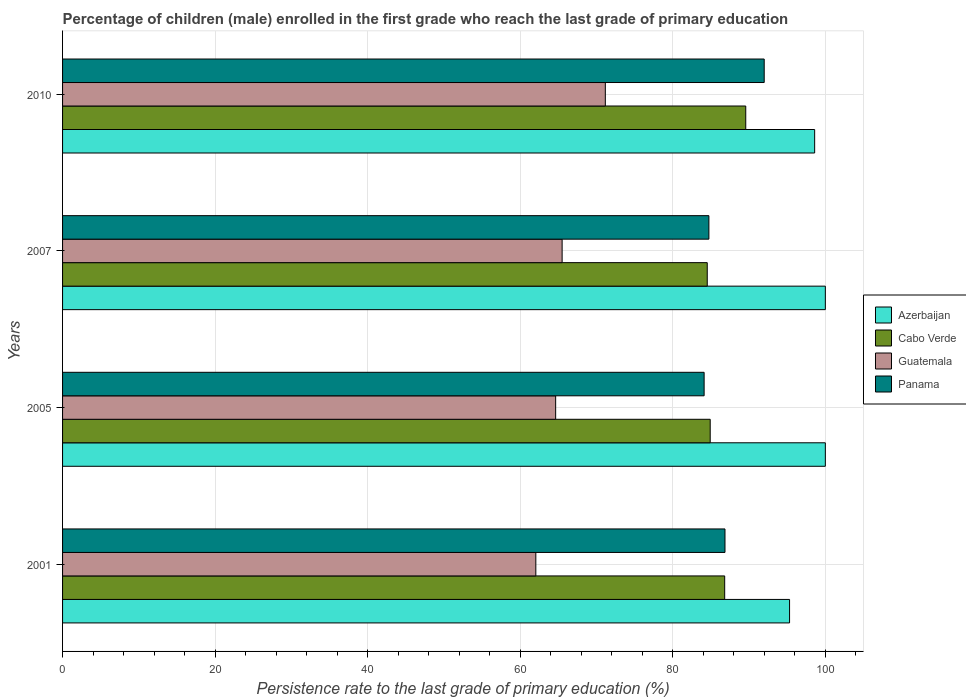How many groups of bars are there?
Ensure brevity in your answer.  4. How many bars are there on the 4th tick from the top?
Your answer should be compact. 4. What is the persistence rate of children in Cabo Verde in 2001?
Give a very brief answer. 86.81. Across all years, what is the minimum persistence rate of children in Cabo Verde?
Offer a terse response. 84.52. What is the total persistence rate of children in Cabo Verde in the graph?
Offer a very short reply. 345.8. What is the difference between the persistence rate of children in Cabo Verde in 2001 and that in 2005?
Your response must be concise. 1.9. What is the difference between the persistence rate of children in Cabo Verde in 2007 and the persistence rate of children in Guatemala in 2001?
Provide a short and direct response. 22.47. What is the average persistence rate of children in Azerbaijan per year?
Offer a very short reply. 98.48. In the year 2007, what is the difference between the persistence rate of children in Guatemala and persistence rate of children in Azerbaijan?
Provide a succinct answer. -34.51. What is the difference between the highest and the lowest persistence rate of children in Guatemala?
Offer a terse response. 9.11. Is the sum of the persistence rate of children in Panama in 2001 and 2010 greater than the maximum persistence rate of children in Guatemala across all years?
Give a very brief answer. Yes. Is it the case that in every year, the sum of the persistence rate of children in Azerbaijan and persistence rate of children in Guatemala is greater than the sum of persistence rate of children in Cabo Verde and persistence rate of children in Panama?
Offer a very short reply. No. What does the 4th bar from the top in 2005 represents?
Ensure brevity in your answer.  Azerbaijan. What does the 2nd bar from the bottom in 2007 represents?
Your answer should be very brief. Cabo Verde. Is it the case that in every year, the sum of the persistence rate of children in Cabo Verde and persistence rate of children in Panama is greater than the persistence rate of children in Guatemala?
Your answer should be very brief. Yes. How many bars are there?
Offer a very short reply. 16. Are all the bars in the graph horizontal?
Your answer should be very brief. Yes. How many years are there in the graph?
Ensure brevity in your answer.  4. Are the values on the major ticks of X-axis written in scientific E-notation?
Provide a succinct answer. No. Does the graph contain any zero values?
Provide a succinct answer. No. Where does the legend appear in the graph?
Provide a succinct answer. Center right. How are the legend labels stacked?
Your answer should be compact. Vertical. What is the title of the graph?
Ensure brevity in your answer.  Percentage of children (male) enrolled in the first grade who reach the last grade of primary education. Does "Bolivia" appear as one of the legend labels in the graph?
Give a very brief answer. No. What is the label or title of the X-axis?
Your answer should be compact. Persistence rate to the last grade of primary education (%). What is the Persistence rate to the last grade of primary education (%) of Azerbaijan in 2001?
Offer a terse response. 95.31. What is the Persistence rate to the last grade of primary education (%) of Cabo Verde in 2001?
Keep it short and to the point. 86.81. What is the Persistence rate to the last grade of primary education (%) in Guatemala in 2001?
Your answer should be very brief. 62.05. What is the Persistence rate to the last grade of primary education (%) in Panama in 2001?
Ensure brevity in your answer.  86.84. What is the Persistence rate to the last grade of primary education (%) in Azerbaijan in 2005?
Offer a very short reply. 100. What is the Persistence rate to the last grade of primary education (%) in Cabo Verde in 2005?
Your response must be concise. 84.91. What is the Persistence rate to the last grade of primary education (%) of Guatemala in 2005?
Your answer should be compact. 64.65. What is the Persistence rate to the last grade of primary education (%) of Panama in 2005?
Your response must be concise. 84.11. What is the Persistence rate to the last grade of primary education (%) in Cabo Verde in 2007?
Keep it short and to the point. 84.52. What is the Persistence rate to the last grade of primary education (%) of Guatemala in 2007?
Your response must be concise. 65.49. What is the Persistence rate to the last grade of primary education (%) in Panama in 2007?
Give a very brief answer. 84.73. What is the Persistence rate to the last grade of primary education (%) of Azerbaijan in 2010?
Provide a short and direct response. 98.6. What is the Persistence rate to the last grade of primary education (%) in Cabo Verde in 2010?
Make the answer very short. 89.57. What is the Persistence rate to the last grade of primary education (%) of Guatemala in 2010?
Ensure brevity in your answer.  71.16. What is the Persistence rate to the last grade of primary education (%) of Panama in 2010?
Keep it short and to the point. 91.99. Across all years, what is the maximum Persistence rate to the last grade of primary education (%) of Cabo Verde?
Provide a succinct answer. 89.57. Across all years, what is the maximum Persistence rate to the last grade of primary education (%) in Guatemala?
Ensure brevity in your answer.  71.16. Across all years, what is the maximum Persistence rate to the last grade of primary education (%) of Panama?
Offer a terse response. 91.99. Across all years, what is the minimum Persistence rate to the last grade of primary education (%) of Azerbaijan?
Offer a very short reply. 95.31. Across all years, what is the minimum Persistence rate to the last grade of primary education (%) of Cabo Verde?
Your answer should be compact. 84.52. Across all years, what is the minimum Persistence rate to the last grade of primary education (%) in Guatemala?
Offer a very short reply. 62.05. Across all years, what is the minimum Persistence rate to the last grade of primary education (%) of Panama?
Offer a very short reply. 84.11. What is the total Persistence rate to the last grade of primary education (%) of Azerbaijan in the graph?
Your answer should be compact. 393.91. What is the total Persistence rate to the last grade of primary education (%) in Cabo Verde in the graph?
Provide a short and direct response. 345.8. What is the total Persistence rate to the last grade of primary education (%) in Guatemala in the graph?
Your answer should be compact. 263.34. What is the total Persistence rate to the last grade of primary education (%) of Panama in the graph?
Your response must be concise. 347.67. What is the difference between the Persistence rate to the last grade of primary education (%) of Azerbaijan in 2001 and that in 2005?
Provide a short and direct response. -4.69. What is the difference between the Persistence rate to the last grade of primary education (%) in Cabo Verde in 2001 and that in 2005?
Keep it short and to the point. 1.9. What is the difference between the Persistence rate to the last grade of primary education (%) in Panama in 2001 and that in 2005?
Give a very brief answer. 2.73. What is the difference between the Persistence rate to the last grade of primary education (%) in Azerbaijan in 2001 and that in 2007?
Provide a succinct answer. -4.69. What is the difference between the Persistence rate to the last grade of primary education (%) in Cabo Verde in 2001 and that in 2007?
Provide a short and direct response. 2.29. What is the difference between the Persistence rate to the last grade of primary education (%) in Guatemala in 2001 and that in 2007?
Offer a terse response. -3.45. What is the difference between the Persistence rate to the last grade of primary education (%) in Panama in 2001 and that in 2007?
Keep it short and to the point. 2.11. What is the difference between the Persistence rate to the last grade of primary education (%) in Azerbaijan in 2001 and that in 2010?
Your response must be concise. -3.29. What is the difference between the Persistence rate to the last grade of primary education (%) in Cabo Verde in 2001 and that in 2010?
Offer a terse response. -2.76. What is the difference between the Persistence rate to the last grade of primary education (%) of Guatemala in 2001 and that in 2010?
Make the answer very short. -9.11. What is the difference between the Persistence rate to the last grade of primary education (%) in Panama in 2001 and that in 2010?
Your answer should be compact. -5.14. What is the difference between the Persistence rate to the last grade of primary education (%) of Cabo Verde in 2005 and that in 2007?
Your answer should be compact. 0.39. What is the difference between the Persistence rate to the last grade of primary education (%) in Guatemala in 2005 and that in 2007?
Offer a terse response. -0.85. What is the difference between the Persistence rate to the last grade of primary education (%) in Panama in 2005 and that in 2007?
Ensure brevity in your answer.  -0.62. What is the difference between the Persistence rate to the last grade of primary education (%) of Azerbaijan in 2005 and that in 2010?
Keep it short and to the point. 1.4. What is the difference between the Persistence rate to the last grade of primary education (%) of Cabo Verde in 2005 and that in 2010?
Give a very brief answer. -4.66. What is the difference between the Persistence rate to the last grade of primary education (%) in Guatemala in 2005 and that in 2010?
Give a very brief answer. -6.51. What is the difference between the Persistence rate to the last grade of primary education (%) in Panama in 2005 and that in 2010?
Ensure brevity in your answer.  -7.88. What is the difference between the Persistence rate to the last grade of primary education (%) of Azerbaijan in 2007 and that in 2010?
Your answer should be very brief. 1.4. What is the difference between the Persistence rate to the last grade of primary education (%) of Cabo Verde in 2007 and that in 2010?
Offer a terse response. -5.05. What is the difference between the Persistence rate to the last grade of primary education (%) of Guatemala in 2007 and that in 2010?
Make the answer very short. -5.66. What is the difference between the Persistence rate to the last grade of primary education (%) of Panama in 2007 and that in 2010?
Offer a very short reply. -7.25. What is the difference between the Persistence rate to the last grade of primary education (%) in Azerbaijan in 2001 and the Persistence rate to the last grade of primary education (%) in Cabo Verde in 2005?
Ensure brevity in your answer.  10.4. What is the difference between the Persistence rate to the last grade of primary education (%) of Azerbaijan in 2001 and the Persistence rate to the last grade of primary education (%) of Guatemala in 2005?
Keep it short and to the point. 30.66. What is the difference between the Persistence rate to the last grade of primary education (%) of Azerbaijan in 2001 and the Persistence rate to the last grade of primary education (%) of Panama in 2005?
Give a very brief answer. 11.2. What is the difference between the Persistence rate to the last grade of primary education (%) of Cabo Verde in 2001 and the Persistence rate to the last grade of primary education (%) of Guatemala in 2005?
Provide a short and direct response. 22.16. What is the difference between the Persistence rate to the last grade of primary education (%) in Cabo Verde in 2001 and the Persistence rate to the last grade of primary education (%) in Panama in 2005?
Provide a succinct answer. 2.7. What is the difference between the Persistence rate to the last grade of primary education (%) in Guatemala in 2001 and the Persistence rate to the last grade of primary education (%) in Panama in 2005?
Ensure brevity in your answer.  -22.06. What is the difference between the Persistence rate to the last grade of primary education (%) of Azerbaijan in 2001 and the Persistence rate to the last grade of primary education (%) of Cabo Verde in 2007?
Your answer should be very brief. 10.79. What is the difference between the Persistence rate to the last grade of primary education (%) in Azerbaijan in 2001 and the Persistence rate to the last grade of primary education (%) in Guatemala in 2007?
Your response must be concise. 29.82. What is the difference between the Persistence rate to the last grade of primary education (%) in Azerbaijan in 2001 and the Persistence rate to the last grade of primary education (%) in Panama in 2007?
Provide a short and direct response. 10.58. What is the difference between the Persistence rate to the last grade of primary education (%) of Cabo Verde in 2001 and the Persistence rate to the last grade of primary education (%) of Guatemala in 2007?
Offer a terse response. 21.31. What is the difference between the Persistence rate to the last grade of primary education (%) of Cabo Verde in 2001 and the Persistence rate to the last grade of primary education (%) of Panama in 2007?
Your answer should be very brief. 2.07. What is the difference between the Persistence rate to the last grade of primary education (%) in Guatemala in 2001 and the Persistence rate to the last grade of primary education (%) in Panama in 2007?
Ensure brevity in your answer.  -22.69. What is the difference between the Persistence rate to the last grade of primary education (%) of Azerbaijan in 2001 and the Persistence rate to the last grade of primary education (%) of Cabo Verde in 2010?
Provide a succinct answer. 5.74. What is the difference between the Persistence rate to the last grade of primary education (%) in Azerbaijan in 2001 and the Persistence rate to the last grade of primary education (%) in Guatemala in 2010?
Provide a short and direct response. 24.15. What is the difference between the Persistence rate to the last grade of primary education (%) of Azerbaijan in 2001 and the Persistence rate to the last grade of primary education (%) of Panama in 2010?
Make the answer very short. 3.32. What is the difference between the Persistence rate to the last grade of primary education (%) in Cabo Verde in 2001 and the Persistence rate to the last grade of primary education (%) in Guatemala in 2010?
Offer a very short reply. 15.65. What is the difference between the Persistence rate to the last grade of primary education (%) in Cabo Verde in 2001 and the Persistence rate to the last grade of primary education (%) in Panama in 2010?
Offer a very short reply. -5.18. What is the difference between the Persistence rate to the last grade of primary education (%) in Guatemala in 2001 and the Persistence rate to the last grade of primary education (%) in Panama in 2010?
Your answer should be compact. -29.94. What is the difference between the Persistence rate to the last grade of primary education (%) in Azerbaijan in 2005 and the Persistence rate to the last grade of primary education (%) in Cabo Verde in 2007?
Your answer should be very brief. 15.48. What is the difference between the Persistence rate to the last grade of primary education (%) in Azerbaijan in 2005 and the Persistence rate to the last grade of primary education (%) in Guatemala in 2007?
Your response must be concise. 34.51. What is the difference between the Persistence rate to the last grade of primary education (%) of Azerbaijan in 2005 and the Persistence rate to the last grade of primary education (%) of Panama in 2007?
Offer a terse response. 15.27. What is the difference between the Persistence rate to the last grade of primary education (%) of Cabo Verde in 2005 and the Persistence rate to the last grade of primary education (%) of Guatemala in 2007?
Give a very brief answer. 19.41. What is the difference between the Persistence rate to the last grade of primary education (%) in Cabo Verde in 2005 and the Persistence rate to the last grade of primary education (%) in Panama in 2007?
Provide a short and direct response. 0.17. What is the difference between the Persistence rate to the last grade of primary education (%) in Guatemala in 2005 and the Persistence rate to the last grade of primary education (%) in Panama in 2007?
Give a very brief answer. -20.09. What is the difference between the Persistence rate to the last grade of primary education (%) in Azerbaijan in 2005 and the Persistence rate to the last grade of primary education (%) in Cabo Verde in 2010?
Give a very brief answer. 10.43. What is the difference between the Persistence rate to the last grade of primary education (%) of Azerbaijan in 2005 and the Persistence rate to the last grade of primary education (%) of Guatemala in 2010?
Your response must be concise. 28.84. What is the difference between the Persistence rate to the last grade of primary education (%) in Azerbaijan in 2005 and the Persistence rate to the last grade of primary education (%) in Panama in 2010?
Offer a terse response. 8.01. What is the difference between the Persistence rate to the last grade of primary education (%) of Cabo Verde in 2005 and the Persistence rate to the last grade of primary education (%) of Guatemala in 2010?
Your answer should be compact. 13.75. What is the difference between the Persistence rate to the last grade of primary education (%) of Cabo Verde in 2005 and the Persistence rate to the last grade of primary education (%) of Panama in 2010?
Give a very brief answer. -7.08. What is the difference between the Persistence rate to the last grade of primary education (%) in Guatemala in 2005 and the Persistence rate to the last grade of primary education (%) in Panama in 2010?
Offer a terse response. -27.34. What is the difference between the Persistence rate to the last grade of primary education (%) in Azerbaijan in 2007 and the Persistence rate to the last grade of primary education (%) in Cabo Verde in 2010?
Offer a terse response. 10.43. What is the difference between the Persistence rate to the last grade of primary education (%) in Azerbaijan in 2007 and the Persistence rate to the last grade of primary education (%) in Guatemala in 2010?
Offer a terse response. 28.84. What is the difference between the Persistence rate to the last grade of primary education (%) in Azerbaijan in 2007 and the Persistence rate to the last grade of primary education (%) in Panama in 2010?
Offer a terse response. 8.01. What is the difference between the Persistence rate to the last grade of primary education (%) in Cabo Verde in 2007 and the Persistence rate to the last grade of primary education (%) in Guatemala in 2010?
Offer a very short reply. 13.36. What is the difference between the Persistence rate to the last grade of primary education (%) in Cabo Verde in 2007 and the Persistence rate to the last grade of primary education (%) in Panama in 2010?
Ensure brevity in your answer.  -7.47. What is the difference between the Persistence rate to the last grade of primary education (%) in Guatemala in 2007 and the Persistence rate to the last grade of primary education (%) in Panama in 2010?
Offer a terse response. -26.49. What is the average Persistence rate to the last grade of primary education (%) of Azerbaijan per year?
Your answer should be very brief. 98.48. What is the average Persistence rate to the last grade of primary education (%) of Cabo Verde per year?
Your answer should be compact. 86.45. What is the average Persistence rate to the last grade of primary education (%) in Guatemala per year?
Provide a short and direct response. 65.83. What is the average Persistence rate to the last grade of primary education (%) of Panama per year?
Keep it short and to the point. 86.92. In the year 2001, what is the difference between the Persistence rate to the last grade of primary education (%) of Azerbaijan and Persistence rate to the last grade of primary education (%) of Cabo Verde?
Your response must be concise. 8.5. In the year 2001, what is the difference between the Persistence rate to the last grade of primary education (%) of Azerbaijan and Persistence rate to the last grade of primary education (%) of Guatemala?
Your response must be concise. 33.26. In the year 2001, what is the difference between the Persistence rate to the last grade of primary education (%) in Azerbaijan and Persistence rate to the last grade of primary education (%) in Panama?
Ensure brevity in your answer.  8.47. In the year 2001, what is the difference between the Persistence rate to the last grade of primary education (%) in Cabo Verde and Persistence rate to the last grade of primary education (%) in Guatemala?
Offer a very short reply. 24.76. In the year 2001, what is the difference between the Persistence rate to the last grade of primary education (%) of Cabo Verde and Persistence rate to the last grade of primary education (%) of Panama?
Give a very brief answer. -0.04. In the year 2001, what is the difference between the Persistence rate to the last grade of primary education (%) in Guatemala and Persistence rate to the last grade of primary education (%) in Panama?
Offer a terse response. -24.8. In the year 2005, what is the difference between the Persistence rate to the last grade of primary education (%) of Azerbaijan and Persistence rate to the last grade of primary education (%) of Cabo Verde?
Your answer should be very brief. 15.09. In the year 2005, what is the difference between the Persistence rate to the last grade of primary education (%) in Azerbaijan and Persistence rate to the last grade of primary education (%) in Guatemala?
Make the answer very short. 35.35. In the year 2005, what is the difference between the Persistence rate to the last grade of primary education (%) in Azerbaijan and Persistence rate to the last grade of primary education (%) in Panama?
Make the answer very short. 15.89. In the year 2005, what is the difference between the Persistence rate to the last grade of primary education (%) of Cabo Verde and Persistence rate to the last grade of primary education (%) of Guatemala?
Provide a succinct answer. 20.26. In the year 2005, what is the difference between the Persistence rate to the last grade of primary education (%) in Cabo Verde and Persistence rate to the last grade of primary education (%) in Panama?
Give a very brief answer. 0.8. In the year 2005, what is the difference between the Persistence rate to the last grade of primary education (%) in Guatemala and Persistence rate to the last grade of primary education (%) in Panama?
Provide a short and direct response. -19.46. In the year 2007, what is the difference between the Persistence rate to the last grade of primary education (%) of Azerbaijan and Persistence rate to the last grade of primary education (%) of Cabo Verde?
Provide a succinct answer. 15.48. In the year 2007, what is the difference between the Persistence rate to the last grade of primary education (%) of Azerbaijan and Persistence rate to the last grade of primary education (%) of Guatemala?
Your answer should be very brief. 34.51. In the year 2007, what is the difference between the Persistence rate to the last grade of primary education (%) in Azerbaijan and Persistence rate to the last grade of primary education (%) in Panama?
Your response must be concise. 15.27. In the year 2007, what is the difference between the Persistence rate to the last grade of primary education (%) of Cabo Verde and Persistence rate to the last grade of primary education (%) of Guatemala?
Provide a succinct answer. 19.03. In the year 2007, what is the difference between the Persistence rate to the last grade of primary education (%) in Cabo Verde and Persistence rate to the last grade of primary education (%) in Panama?
Your response must be concise. -0.22. In the year 2007, what is the difference between the Persistence rate to the last grade of primary education (%) in Guatemala and Persistence rate to the last grade of primary education (%) in Panama?
Make the answer very short. -19.24. In the year 2010, what is the difference between the Persistence rate to the last grade of primary education (%) in Azerbaijan and Persistence rate to the last grade of primary education (%) in Cabo Verde?
Ensure brevity in your answer.  9.03. In the year 2010, what is the difference between the Persistence rate to the last grade of primary education (%) of Azerbaijan and Persistence rate to the last grade of primary education (%) of Guatemala?
Your response must be concise. 27.44. In the year 2010, what is the difference between the Persistence rate to the last grade of primary education (%) in Azerbaijan and Persistence rate to the last grade of primary education (%) in Panama?
Ensure brevity in your answer.  6.61. In the year 2010, what is the difference between the Persistence rate to the last grade of primary education (%) of Cabo Verde and Persistence rate to the last grade of primary education (%) of Guatemala?
Ensure brevity in your answer.  18.41. In the year 2010, what is the difference between the Persistence rate to the last grade of primary education (%) of Cabo Verde and Persistence rate to the last grade of primary education (%) of Panama?
Provide a succinct answer. -2.42. In the year 2010, what is the difference between the Persistence rate to the last grade of primary education (%) of Guatemala and Persistence rate to the last grade of primary education (%) of Panama?
Your response must be concise. -20.83. What is the ratio of the Persistence rate to the last grade of primary education (%) of Azerbaijan in 2001 to that in 2005?
Give a very brief answer. 0.95. What is the ratio of the Persistence rate to the last grade of primary education (%) in Cabo Verde in 2001 to that in 2005?
Keep it short and to the point. 1.02. What is the ratio of the Persistence rate to the last grade of primary education (%) in Guatemala in 2001 to that in 2005?
Your response must be concise. 0.96. What is the ratio of the Persistence rate to the last grade of primary education (%) of Panama in 2001 to that in 2005?
Provide a short and direct response. 1.03. What is the ratio of the Persistence rate to the last grade of primary education (%) of Azerbaijan in 2001 to that in 2007?
Give a very brief answer. 0.95. What is the ratio of the Persistence rate to the last grade of primary education (%) of Cabo Verde in 2001 to that in 2007?
Your answer should be compact. 1.03. What is the ratio of the Persistence rate to the last grade of primary education (%) of Panama in 2001 to that in 2007?
Keep it short and to the point. 1.02. What is the ratio of the Persistence rate to the last grade of primary education (%) of Azerbaijan in 2001 to that in 2010?
Make the answer very short. 0.97. What is the ratio of the Persistence rate to the last grade of primary education (%) of Cabo Verde in 2001 to that in 2010?
Your answer should be very brief. 0.97. What is the ratio of the Persistence rate to the last grade of primary education (%) of Guatemala in 2001 to that in 2010?
Offer a terse response. 0.87. What is the ratio of the Persistence rate to the last grade of primary education (%) in Panama in 2001 to that in 2010?
Your response must be concise. 0.94. What is the ratio of the Persistence rate to the last grade of primary education (%) in Azerbaijan in 2005 to that in 2007?
Ensure brevity in your answer.  1. What is the ratio of the Persistence rate to the last grade of primary education (%) of Guatemala in 2005 to that in 2007?
Provide a short and direct response. 0.99. What is the ratio of the Persistence rate to the last grade of primary education (%) in Azerbaijan in 2005 to that in 2010?
Your response must be concise. 1.01. What is the ratio of the Persistence rate to the last grade of primary education (%) in Cabo Verde in 2005 to that in 2010?
Your answer should be very brief. 0.95. What is the ratio of the Persistence rate to the last grade of primary education (%) in Guatemala in 2005 to that in 2010?
Your response must be concise. 0.91. What is the ratio of the Persistence rate to the last grade of primary education (%) of Panama in 2005 to that in 2010?
Your answer should be very brief. 0.91. What is the ratio of the Persistence rate to the last grade of primary education (%) in Azerbaijan in 2007 to that in 2010?
Offer a terse response. 1.01. What is the ratio of the Persistence rate to the last grade of primary education (%) in Cabo Verde in 2007 to that in 2010?
Your response must be concise. 0.94. What is the ratio of the Persistence rate to the last grade of primary education (%) in Guatemala in 2007 to that in 2010?
Your answer should be compact. 0.92. What is the ratio of the Persistence rate to the last grade of primary education (%) in Panama in 2007 to that in 2010?
Provide a short and direct response. 0.92. What is the difference between the highest and the second highest Persistence rate to the last grade of primary education (%) in Azerbaijan?
Provide a succinct answer. 0. What is the difference between the highest and the second highest Persistence rate to the last grade of primary education (%) of Cabo Verde?
Your response must be concise. 2.76. What is the difference between the highest and the second highest Persistence rate to the last grade of primary education (%) in Guatemala?
Your answer should be very brief. 5.66. What is the difference between the highest and the second highest Persistence rate to the last grade of primary education (%) in Panama?
Offer a very short reply. 5.14. What is the difference between the highest and the lowest Persistence rate to the last grade of primary education (%) of Azerbaijan?
Make the answer very short. 4.69. What is the difference between the highest and the lowest Persistence rate to the last grade of primary education (%) in Cabo Verde?
Provide a short and direct response. 5.05. What is the difference between the highest and the lowest Persistence rate to the last grade of primary education (%) in Guatemala?
Offer a very short reply. 9.11. What is the difference between the highest and the lowest Persistence rate to the last grade of primary education (%) in Panama?
Offer a very short reply. 7.88. 